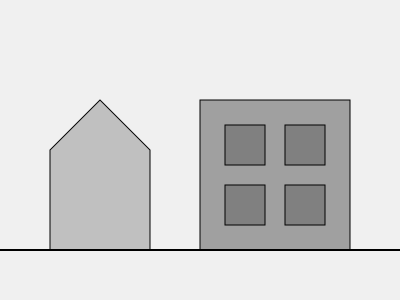In the cityscape sketch above, identify the primary Brutalist design elements and explain how they contribute to the overall aesthetic of the buildings depicted. To identify the Brutalist design elements in this cityscape sketch, we need to analyze the following aspects:

1. Geometric Shapes: 
   - The buildings are composed of simple, bold geometric forms.
   - The structure on the left features a triangular roof and rectangular body.
   - The building on the right is a perfect rectangle.

2. Exposed Concrete Appearance:
   - The gray tones used in the sketch suggest exposed concrete surfaces, a hallmark of Brutalism.
   - Different shades indicate variations in concrete textures or forms.

3. Repetitive Patterns:
   - The right building showcases a grid of identical windows, a common Brutalist feature.
   - This repetition creates a sense of order and modularity.

4. Lack of Ornamentation:
   - The buildings are devoid of decorative elements, focusing on raw structural forms.
   - This absence of embellishment is a key principle of Brutalist design.

5. Monolithic Appearance:
   - Both structures appear as solid, imposing forms, emphasizing mass and weight.
   - This contributes to the monumental quality often associated with Brutalism.

6. Emphasis on Functionality:
   - The simple, straightforward design suggests a focus on function over form.
   - Windows are uniform and utilitarian, prioritizing purpose over aesthetics.

These elements collectively create an aesthetic that is:
- Bold and imposing
- Honest in its display of materials and structure
- Functional and utilitarian
- Characterized by a raw, unadorned beauty

This approach to design is quintessentially Brutalist, showcasing the movement's core principles of exposed materials, geometric clarity, and celebration of structural elements.
Answer: Geometric shapes, exposed concrete appearance, repetitive patterns, lack of ornamentation, monolithic form, and emphasis on functionality. 